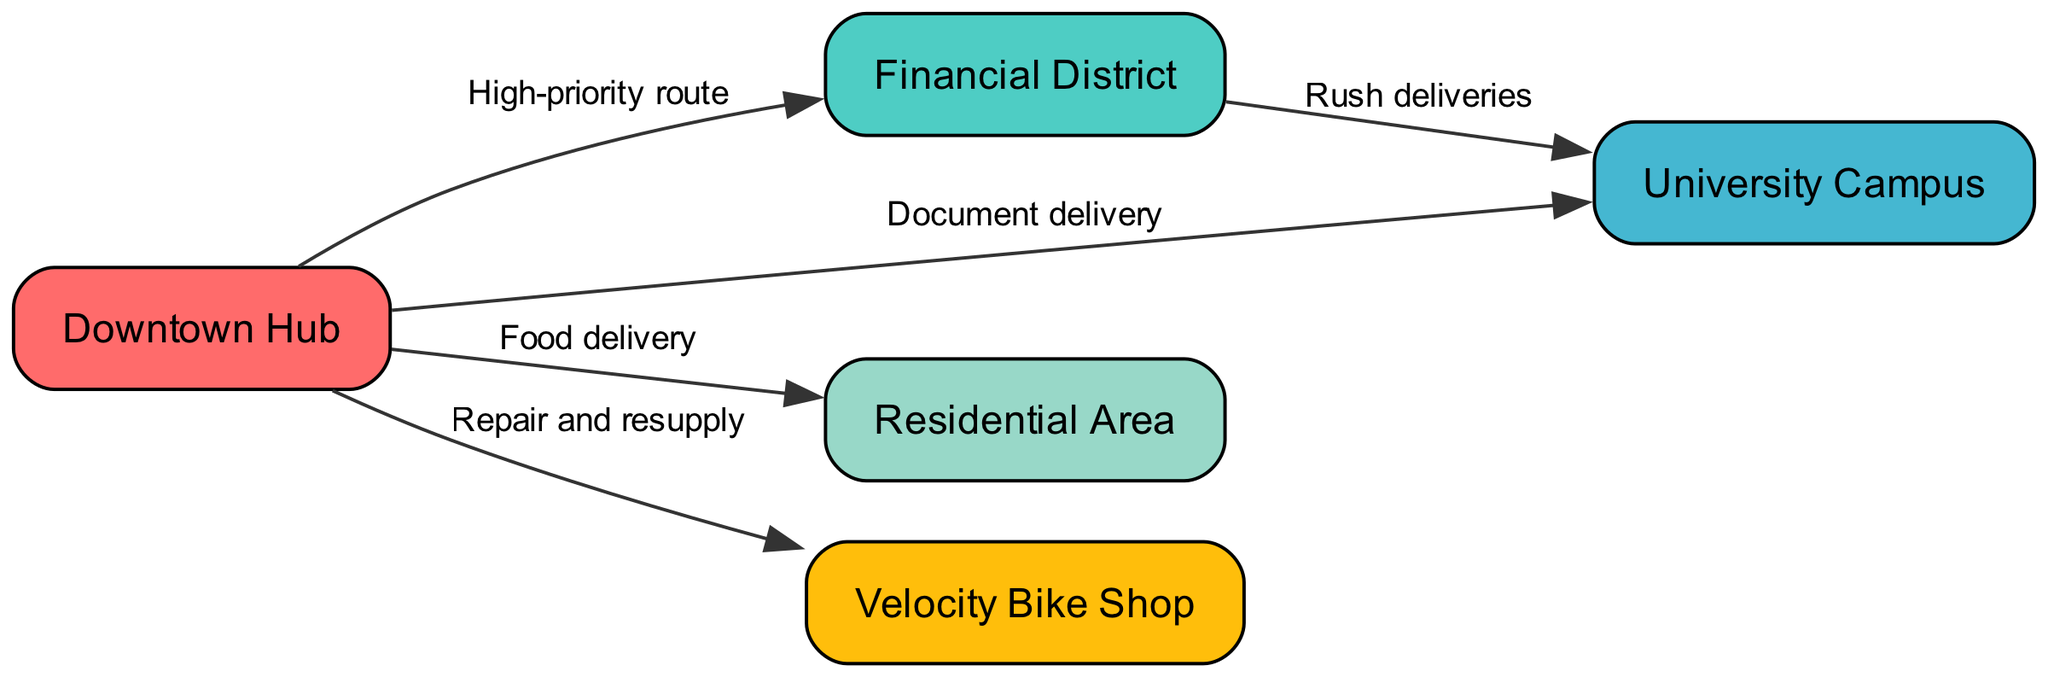What is the total number of nodes in the diagram? The diagram includes five nodes: Downtown Hub, Financial District, University Campus, Residential Area, and Velocity Bike Shop. Counting these, we find that there are five distinct locations represented.
Answer: 5 What is the main function of the route from downtown to the bikeshop? The diagram labels the connection from Downtown Hub to Velocity Bike Shop as "Repair and resupply." This indicates that this route primarily serves the purpose of getting repairs done and obtaining supplies for the bike messenger.
Answer: Repair and resupply Which two locations are connected by a high-priority route? The diagram shows a direct edge labeled "High-priority route" connecting Downtown Hub to Financial District. This indicates that this route is the most urgent or prioritized among the routes depicted in the diagram.
Answer: Downtown Hub and Financial District How many delivery types are indicated in the delivery zones? The diagram specifies three types of deliveries emanating from Downtown Hub: document delivery to University Campus, food delivery to Residential Area, and repair and resupply to Velocity Bike Shop. Thus, we can count these distinct delivery types.
Answer: 3 Which node does not have any outgoing edges? In analyzing the edges from each node, we see that Velocity Bike Shop does not connect outward to any other nodes. Therefore, it has no outgoing edges.
Answer: Velocity Bike Shop What is the delivery goal of the route from financial to university? The edge between financial and university is labeled "Rush deliveries," indicating that this connection is dedicated to the urgent or expedited delivery of items between these two locations.
Answer: Rush deliveries Is there a direct route between residential and financial? The diagram does not show a direct edge connecting Residential Area to Financial District, which means that there is no single, clear route for bike messengers between these two nodes.
Answer: No Which route involves food delivery? The edge from Downtown Hub to Residential Area is labeled "Food delivery," explicitly indicating that this route is utilized when delivering food items.
Answer: Food delivery 